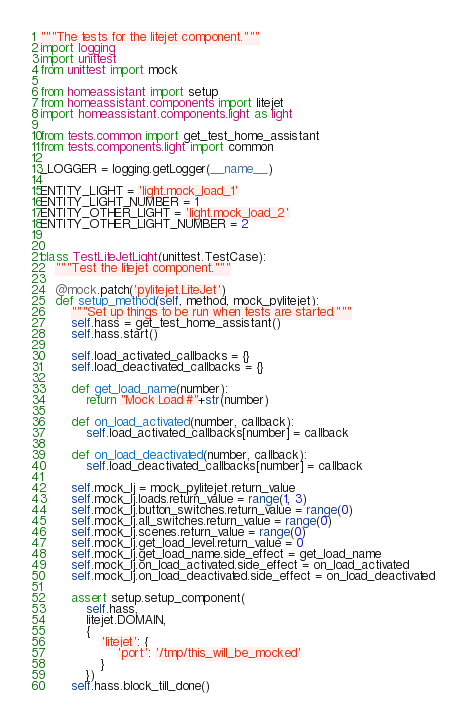Convert code to text. <code><loc_0><loc_0><loc_500><loc_500><_Python_>"""The tests for the litejet component."""
import logging
import unittest
from unittest import mock

from homeassistant import setup
from homeassistant.components import litejet
import homeassistant.components.light as light

from tests.common import get_test_home_assistant
from tests.components.light import common

_LOGGER = logging.getLogger(__name__)

ENTITY_LIGHT = 'light.mock_load_1'
ENTITY_LIGHT_NUMBER = 1
ENTITY_OTHER_LIGHT = 'light.mock_load_2'
ENTITY_OTHER_LIGHT_NUMBER = 2


class TestLiteJetLight(unittest.TestCase):
    """Test the litejet component."""

    @mock.patch('pylitejet.LiteJet')
    def setup_method(self, method, mock_pylitejet):
        """Set up things to be run when tests are started."""
        self.hass = get_test_home_assistant()
        self.hass.start()

        self.load_activated_callbacks = {}
        self.load_deactivated_callbacks = {}

        def get_load_name(number):
            return "Mock Load #"+str(number)

        def on_load_activated(number, callback):
            self.load_activated_callbacks[number] = callback

        def on_load_deactivated(number, callback):
            self.load_deactivated_callbacks[number] = callback

        self.mock_lj = mock_pylitejet.return_value
        self.mock_lj.loads.return_value = range(1, 3)
        self.mock_lj.button_switches.return_value = range(0)
        self.mock_lj.all_switches.return_value = range(0)
        self.mock_lj.scenes.return_value = range(0)
        self.mock_lj.get_load_level.return_value = 0
        self.mock_lj.get_load_name.side_effect = get_load_name
        self.mock_lj.on_load_activated.side_effect = on_load_activated
        self.mock_lj.on_load_deactivated.side_effect = on_load_deactivated

        assert setup.setup_component(
            self.hass,
            litejet.DOMAIN,
            {
                'litejet': {
                    'port': '/tmp/this_will_be_mocked'
                }
            })
        self.hass.block_till_done()
</code> 